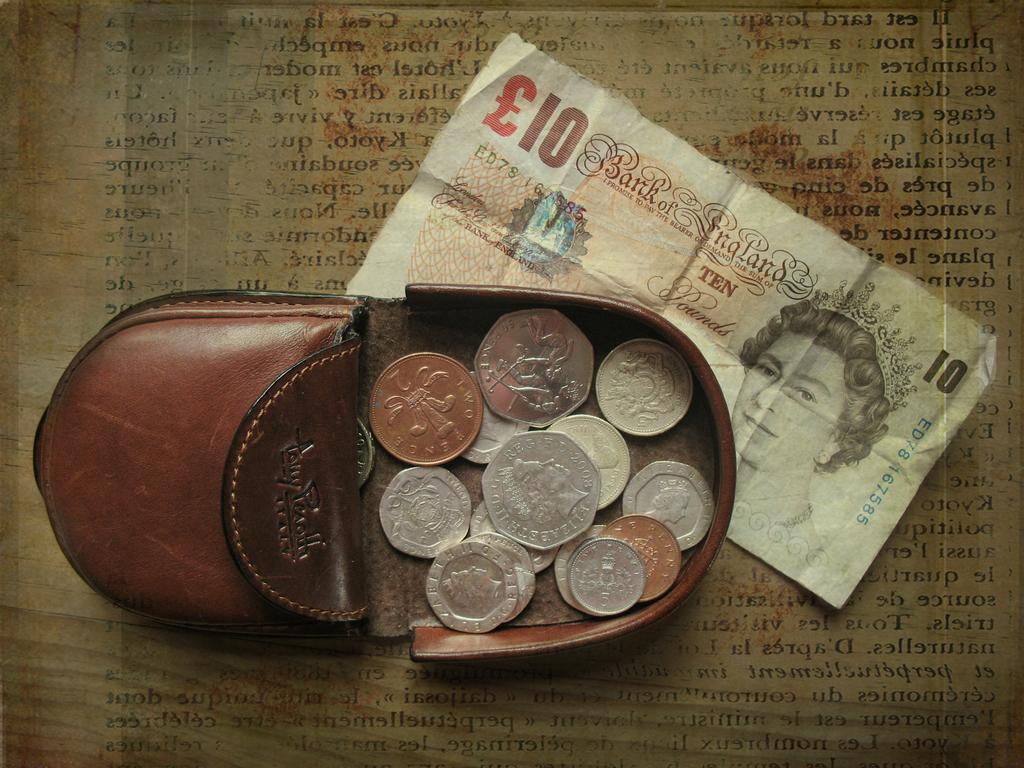<image>
Describe the image concisely. the number 10 is on the paper bill 